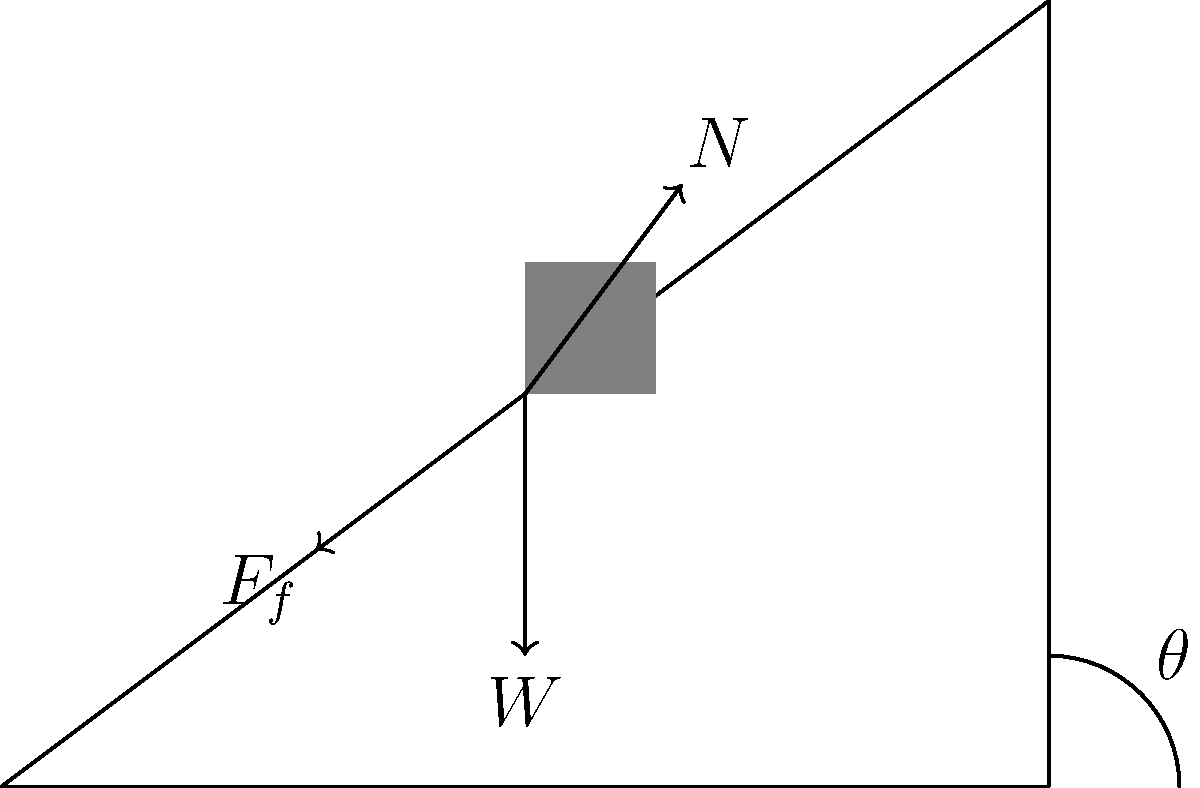In a parliamentary election simulation, a block representing a political party is placed on an inclined plane at an angle $\theta$ to the horizontal. The block's weight $W$, the normal force $N$, and the friction force $F_f$ are shown in the diagram. If the coefficient of static friction between the block and the plane is $\mu_s$, what is the maximum angle $\theta$ at which the block will remain stationary, analogous to a party maintaining its position in the polls? To solve this problem, we'll follow these steps:

1. Identify the forces acting on the block:
   - Weight ($W$) acting downwards
   - Normal force ($N$) perpendicular to the plane
   - Friction force ($F_f$) parallel to the plane, opposing motion

2. Resolve the weight into components parallel and perpendicular to the plane:
   - Perpendicular component: $W \cos\theta$
   - Parallel component: $W \sin\theta$

3. For the block to remain stationary, two conditions must be met:
   a) The normal force must balance the perpendicular component of weight:
      $N = W \cos\theta$
   b) The friction force must balance the parallel component of weight:
      $F_f = W \sin\theta$

4. The maximum friction force is given by:
   $F_f (\text{max}) = \mu_s N$

5. At the maximum angle, the friction force equals its maximum value:
   $W \sin\theta = \mu_s N = \mu_s W \cos\theta$

6. Divide both sides by $W \cos\theta$:
   $\frac{\sin\theta}{\cos\theta} = \mu_s$

7. Recognize that $\frac{\sin\theta}{\cos\theta} = \tan\theta$:
   $\tan\theta = \mu_s$

8. Solve for $\theta$:
   $\theta = \arctan(\mu_s)$

This angle represents the maximum incline at which the block (political party) will remain stationary (maintain its position) before sliding down (losing support).
Answer: $\theta = \arctan(\mu_s)$ 